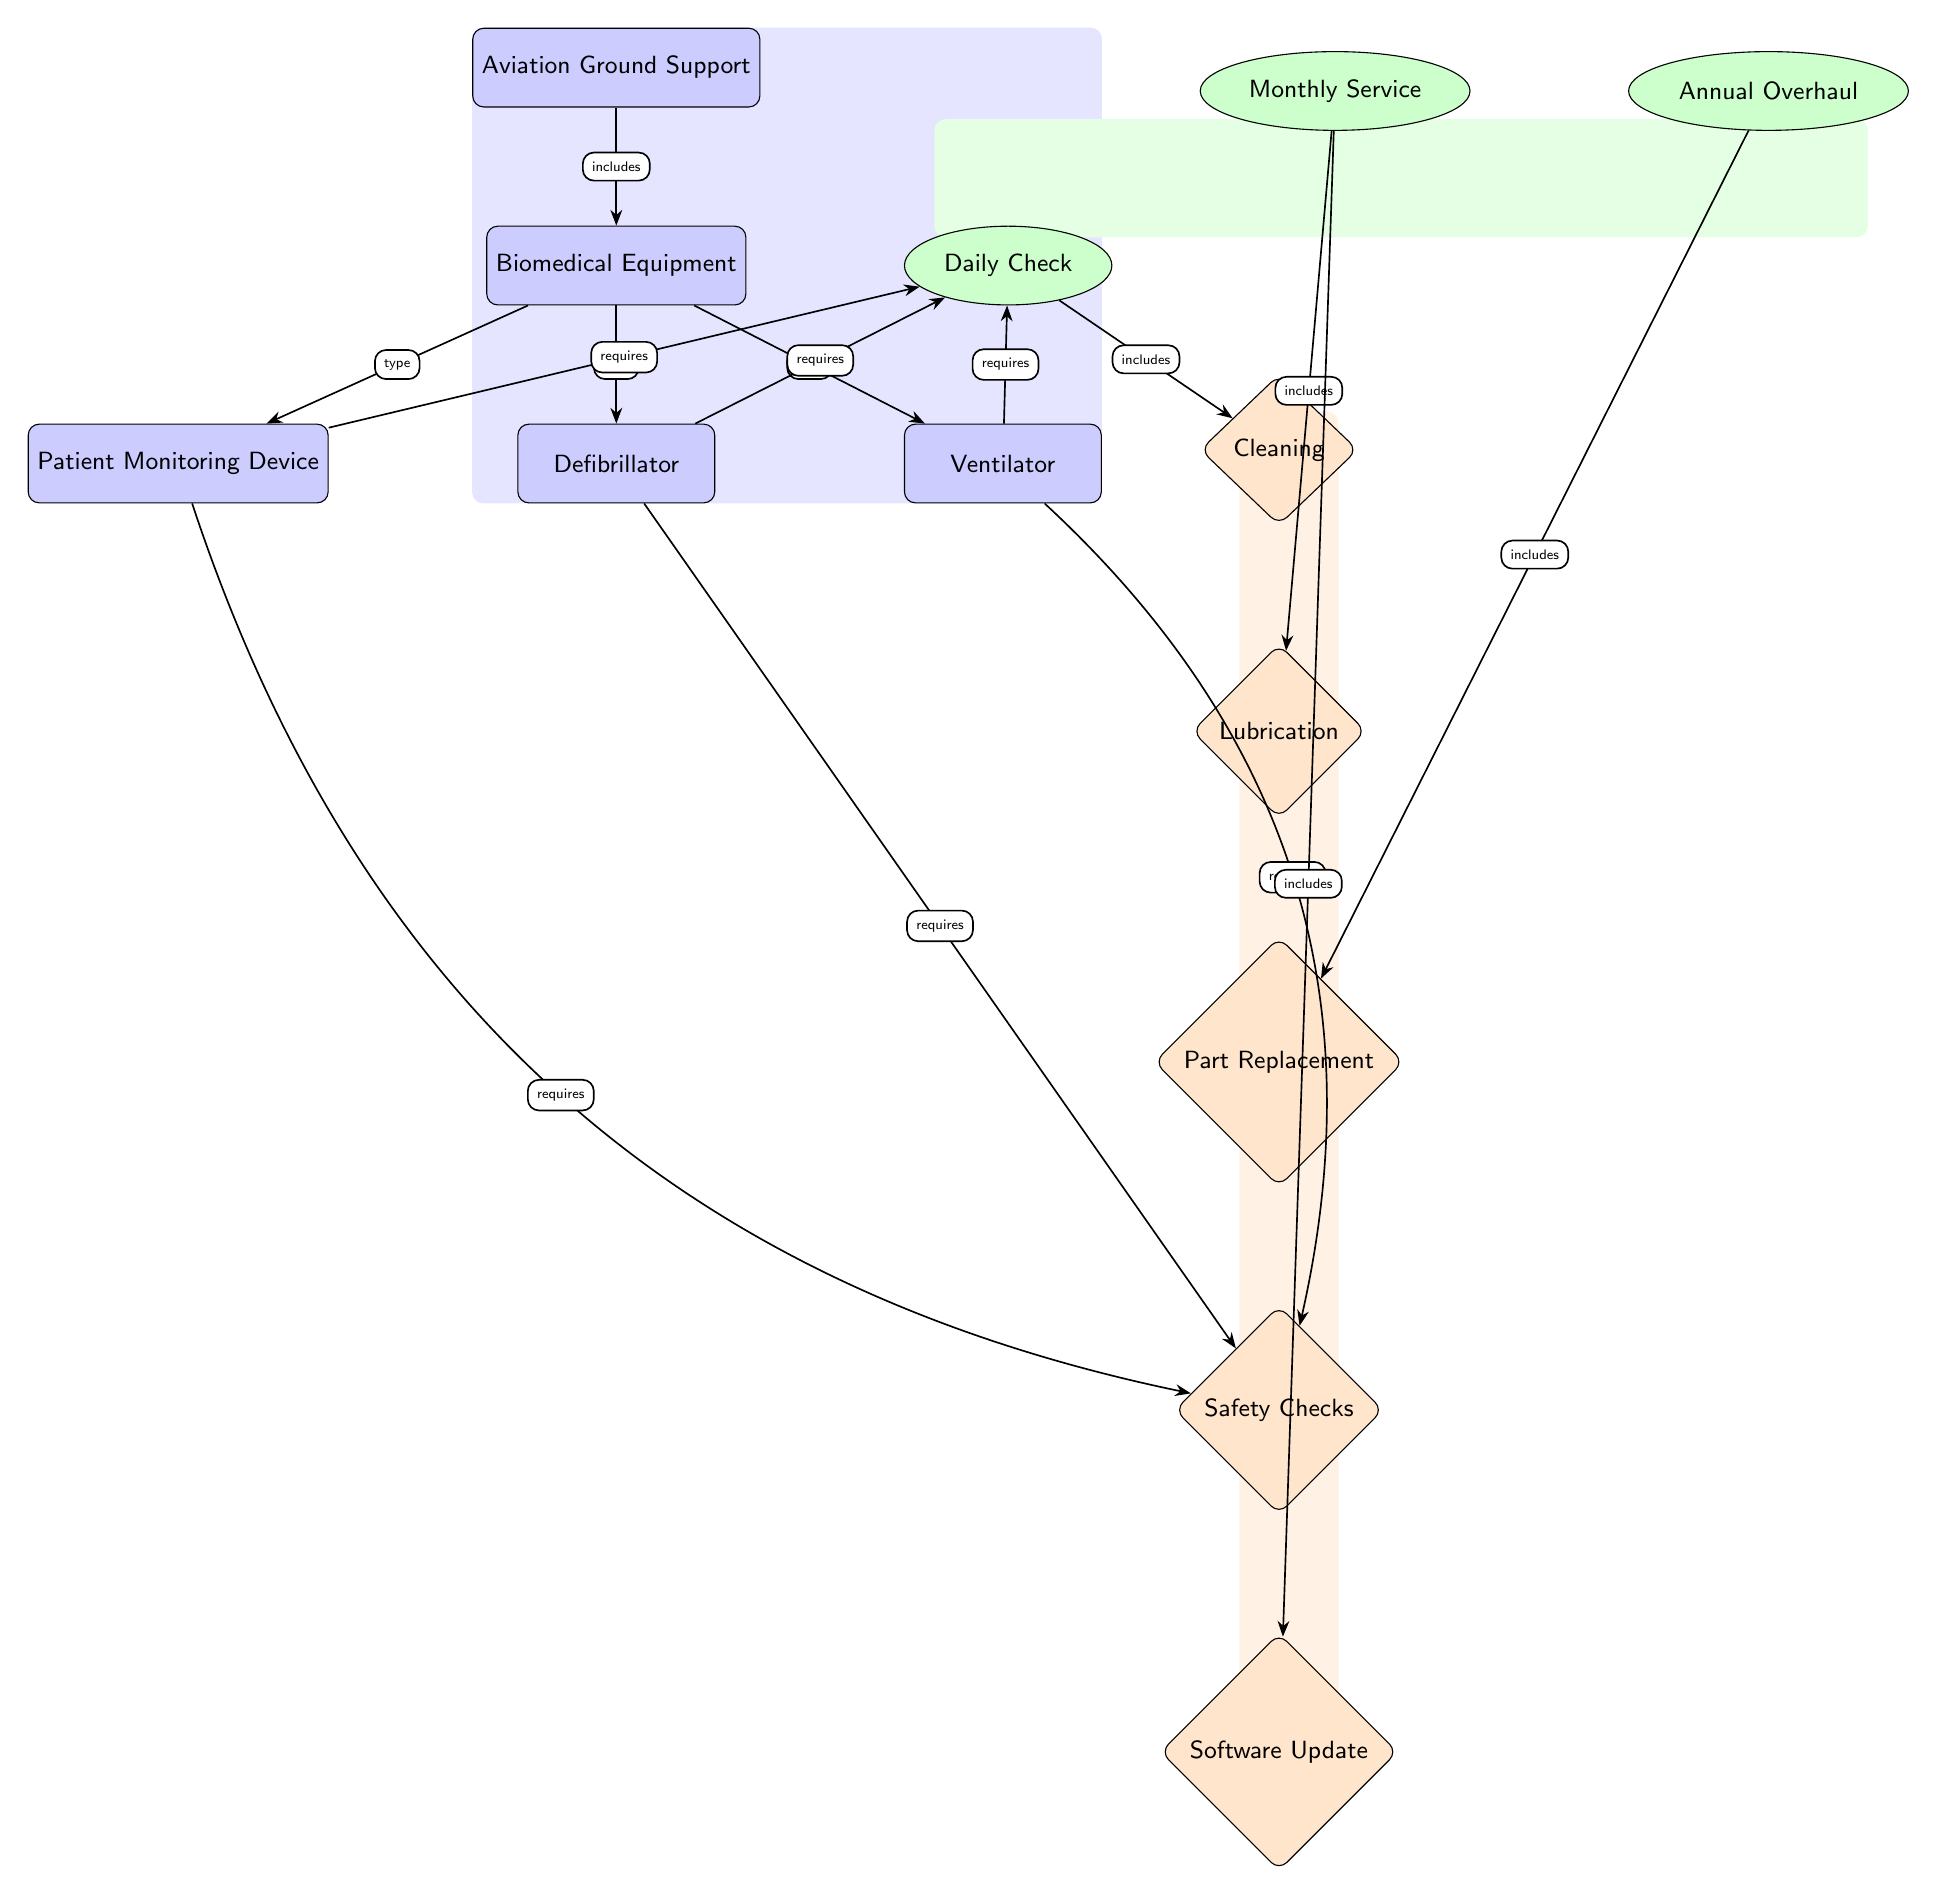What is the main equipment category shown in the diagram? The diagram starts with a node labeled 'Aviation Ground Support', which represents the main category of equipment.
Answer: Aviation Ground Support How many types of biomedical equipment are listed? There are three nodes labeled 'Patient Monitoring Device', 'Defibrillator', and 'Ventilator'. This indicates there are three types of biomedical equipment.
Answer: 3 What task is required for all biomedical equipment? Each piece of biomedical equipment requires a 'Daily Check', as indicated by the edges connecting the equipment nodes to the task node.
Answer: Daily Check Which subtask is included in the 'Monthly Service'? The node labeled 'Lubrication' is connected to the 'Monthly Service' task, indicating that it is included in that category.
Answer: Lubrication Which task has a subtask focused on 'Software Update'? The task node 'Monthly Service' is linked to 'Software Update', showing that it includes that specific subtask.
Answer: Monthly Service What type of checks are required for patient monitoring devices beyond the daily check? The diagram indicates that 'Safety Checks' are specifically required for the 'Patient Monitoring Device', beyond the daily check task.
Answer: Safety Checks How does the diagram categorize the maintenance tasks? The diagram categorizes maintenance tasks into 'Daily Check', 'Monthly Service', and 'Annual Overhaul' based on the links from the biomedical equipment to these tasks.
Answer: Maintenance Tasks What is the relationship between 'Defibrillator' and 'Safety Checks'? The 'Defibrillator' node is directly linked to the 'Safety Checks' subtask, indicating a requirement for safety checks specifically for this equipment type.
Answer: Requires Which task includes 'Part Replacement' as a subtask? The 'Annual Overhaul' task has a subtask labeled 'Part Replacement', showing that this task includes that specific requirement.
Answer: Annual Overhaul 